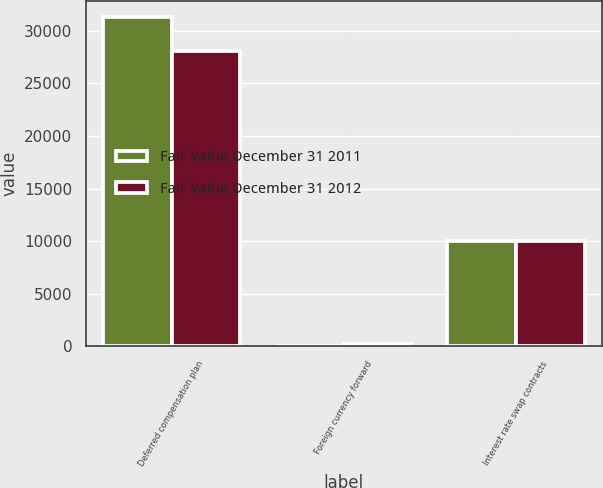Convert chart. <chart><loc_0><loc_0><loc_500><loc_500><stacked_bar_chart><ecel><fcel>Deferred compensation plan<fcel>Foreign currency forward<fcel>Interest rate swap contracts<nl><fcel>Fair Value December 31 2011<fcel>31260<fcel>4<fcel>10000<nl><fcel>Fair Value December 31 2012<fcel>28100<fcel>272<fcel>9989<nl></chart> 